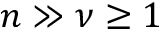<formula> <loc_0><loc_0><loc_500><loc_500>n \gg \nu \geq 1</formula> 